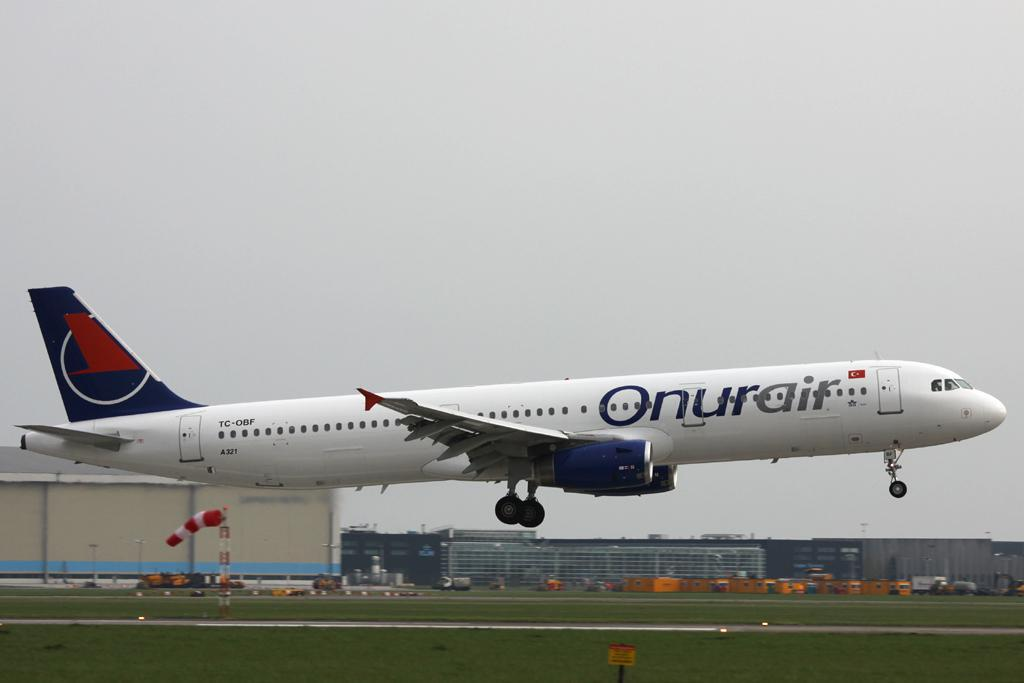<image>
Create a compact narrative representing the image presented. Onurair plane is getting ready to fly in the sky 